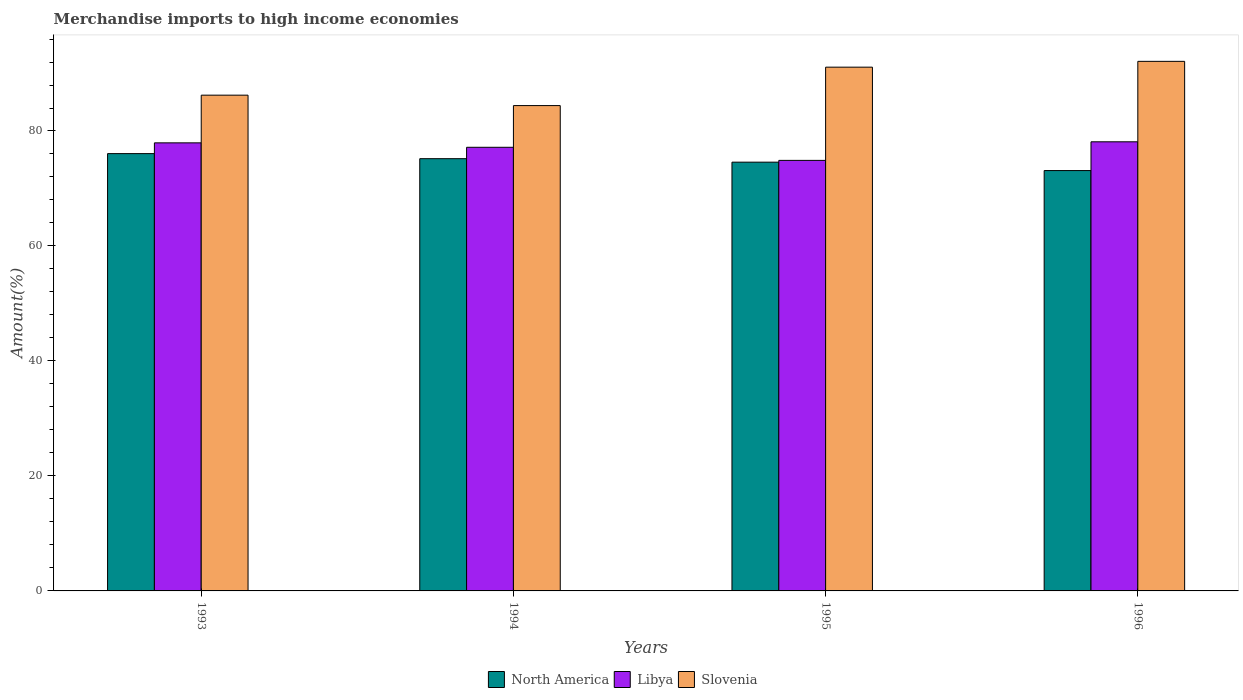Are the number of bars per tick equal to the number of legend labels?
Offer a terse response. Yes. What is the label of the 1st group of bars from the left?
Give a very brief answer. 1993. What is the percentage of amount earned from merchandise imports in North America in 1996?
Provide a short and direct response. 73.12. Across all years, what is the maximum percentage of amount earned from merchandise imports in North America?
Provide a short and direct response. 76.07. Across all years, what is the minimum percentage of amount earned from merchandise imports in Slovenia?
Give a very brief answer. 84.42. In which year was the percentage of amount earned from merchandise imports in Libya maximum?
Provide a short and direct response. 1996. In which year was the percentage of amount earned from merchandise imports in Libya minimum?
Your response must be concise. 1995. What is the total percentage of amount earned from merchandise imports in Slovenia in the graph?
Offer a terse response. 353.87. What is the difference between the percentage of amount earned from merchandise imports in North America in 1993 and that in 1995?
Give a very brief answer. 1.49. What is the difference between the percentage of amount earned from merchandise imports in Slovenia in 1996 and the percentage of amount earned from merchandise imports in Libya in 1995?
Offer a very short reply. 17.23. What is the average percentage of amount earned from merchandise imports in Libya per year?
Offer a terse response. 77.03. In the year 1996, what is the difference between the percentage of amount earned from merchandise imports in Slovenia and percentage of amount earned from merchandise imports in North America?
Your answer should be compact. 19. What is the ratio of the percentage of amount earned from merchandise imports in Slovenia in 1995 to that in 1996?
Keep it short and to the point. 0.99. Is the percentage of amount earned from merchandise imports in Slovenia in 1994 less than that in 1996?
Your answer should be compact. Yes. Is the difference between the percentage of amount earned from merchandise imports in Slovenia in 1995 and 1996 greater than the difference between the percentage of amount earned from merchandise imports in North America in 1995 and 1996?
Provide a succinct answer. No. What is the difference between the highest and the second highest percentage of amount earned from merchandise imports in Libya?
Provide a succinct answer. 0.18. What is the difference between the highest and the lowest percentage of amount earned from merchandise imports in Libya?
Your response must be concise. 3.23. What does the 2nd bar from the left in 1993 represents?
Your answer should be compact. Libya. What does the 2nd bar from the right in 1993 represents?
Give a very brief answer. Libya. Is it the case that in every year, the sum of the percentage of amount earned from merchandise imports in North America and percentage of amount earned from merchandise imports in Slovenia is greater than the percentage of amount earned from merchandise imports in Libya?
Your response must be concise. Yes. What is the difference between two consecutive major ticks on the Y-axis?
Ensure brevity in your answer.  20. Does the graph contain any zero values?
Ensure brevity in your answer.  No. What is the title of the graph?
Provide a short and direct response. Merchandise imports to high income economies. Does "Somalia" appear as one of the legend labels in the graph?
Offer a very short reply. No. What is the label or title of the X-axis?
Keep it short and to the point. Years. What is the label or title of the Y-axis?
Make the answer very short. Amount(%). What is the Amount(%) of North America in 1993?
Your answer should be very brief. 76.07. What is the Amount(%) in Libya in 1993?
Your answer should be very brief. 77.94. What is the Amount(%) of Slovenia in 1993?
Your answer should be very brief. 86.23. What is the Amount(%) of North America in 1994?
Ensure brevity in your answer.  75.18. What is the Amount(%) in Libya in 1994?
Offer a terse response. 77.17. What is the Amount(%) in Slovenia in 1994?
Give a very brief answer. 84.42. What is the Amount(%) in North America in 1995?
Ensure brevity in your answer.  74.58. What is the Amount(%) in Libya in 1995?
Your answer should be compact. 74.89. What is the Amount(%) in Slovenia in 1995?
Ensure brevity in your answer.  91.1. What is the Amount(%) in North America in 1996?
Ensure brevity in your answer.  73.12. What is the Amount(%) of Libya in 1996?
Give a very brief answer. 78.12. What is the Amount(%) in Slovenia in 1996?
Offer a very short reply. 92.11. Across all years, what is the maximum Amount(%) in North America?
Provide a short and direct response. 76.07. Across all years, what is the maximum Amount(%) of Libya?
Make the answer very short. 78.12. Across all years, what is the maximum Amount(%) in Slovenia?
Your answer should be very brief. 92.11. Across all years, what is the minimum Amount(%) of North America?
Offer a terse response. 73.12. Across all years, what is the minimum Amount(%) in Libya?
Your answer should be very brief. 74.89. Across all years, what is the minimum Amount(%) in Slovenia?
Your response must be concise. 84.42. What is the total Amount(%) of North America in the graph?
Provide a succinct answer. 298.94. What is the total Amount(%) in Libya in the graph?
Give a very brief answer. 308.11. What is the total Amount(%) in Slovenia in the graph?
Your answer should be very brief. 353.87. What is the difference between the Amount(%) of North America in 1993 and that in 1994?
Your answer should be compact. 0.88. What is the difference between the Amount(%) of Libya in 1993 and that in 1994?
Provide a short and direct response. 0.77. What is the difference between the Amount(%) of Slovenia in 1993 and that in 1994?
Provide a short and direct response. 1.81. What is the difference between the Amount(%) in North America in 1993 and that in 1995?
Keep it short and to the point. 1.49. What is the difference between the Amount(%) of Libya in 1993 and that in 1995?
Offer a terse response. 3.05. What is the difference between the Amount(%) in Slovenia in 1993 and that in 1995?
Provide a short and direct response. -4.87. What is the difference between the Amount(%) of North America in 1993 and that in 1996?
Your answer should be very brief. 2.95. What is the difference between the Amount(%) of Libya in 1993 and that in 1996?
Keep it short and to the point. -0.18. What is the difference between the Amount(%) of Slovenia in 1993 and that in 1996?
Your response must be concise. -5.88. What is the difference between the Amount(%) in North America in 1994 and that in 1995?
Provide a succinct answer. 0.61. What is the difference between the Amount(%) in Libya in 1994 and that in 1995?
Your answer should be very brief. 2.28. What is the difference between the Amount(%) in Slovenia in 1994 and that in 1995?
Provide a short and direct response. -6.68. What is the difference between the Amount(%) of North America in 1994 and that in 1996?
Ensure brevity in your answer.  2.07. What is the difference between the Amount(%) in Libya in 1994 and that in 1996?
Provide a short and direct response. -0.95. What is the difference between the Amount(%) of Slovenia in 1994 and that in 1996?
Ensure brevity in your answer.  -7.69. What is the difference between the Amount(%) in North America in 1995 and that in 1996?
Your answer should be very brief. 1.46. What is the difference between the Amount(%) of Libya in 1995 and that in 1996?
Keep it short and to the point. -3.23. What is the difference between the Amount(%) in Slovenia in 1995 and that in 1996?
Your answer should be very brief. -1.01. What is the difference between the Amount(%) in North America in 1993 and the Amount(%) in Libya in 1994?
Give a very brief answer. -1.1. What is the difference between the Amount(%) in North America in 1993 and the Amount(%) in Slovenia in 1994?
Your answer should be compact. -8.36. What is the difference between the Amount(%) of Libya in 1993 and the Amount(%) of Slovenia in 1994?
Keep it short and to the point. -6.48. What is the difference between the Amount(%) of North America in 1993 and the Amount(%) of Libya in 1995?
Ensure brevity in your answer.  1.18. What is the difference between the Amount(%) of North America in 1993 and the Amount(%) of Slovenia in 1995?
Your answer should be very brief. -15.04. What is the difference between the Amount(%) in Libya in 1993 and the Amount(%) in Slovenia in 1995?
Make the answer very short. -13.16. What is the difference between the Amount(%) of North America in 1993 and the Amount(%) of Libya in 1996?
Keep it short and to the point. -2.06. What is the difference between the Amount(%) in North America in 1993 and the Amount(%) in Slovenia in 1996?
Give a very brief answer. -16.05. What is the difference between the Amount(%) in Libya in 1993 and the Amount(%) in Slovenia in 1996?
Give a very brief answer. -14.18. What is the difference between the Amount(%) in North America in 1994 and the Amount(%) in Libya in 1995?
Keep it short and to the point. 0.3. What is the difference between the Amount(%) in North America in 1994 and the Amount(%) in Slovenia in 1995?
Keep it short and to the point. -15.92. What is the difference between the Amount(%) in Libya in 1994 and the Amount(%) in Slovenia in 1995?
Offer a very short reply. -13.94. What is the difference between the Amount(%) in North America in 1994 and the Amount(%) in Libya in 1996?
Your answer should be compact. -2.94. What is the difference between the Amount(%) in North America in 1994 and the Amount(%) in Slovenia in 1996?
Provide a succinct answer. -16.93. What is the difference between the Amount(%) of Libya in 1994 and the Amount(%) of Slovenia in 1996?
Provide a succinct answer. -14.95. What is the difference between the Amount(%) of North America in 1995 and the Amount(%) of Libya in 1996?
Provide a succinct answer. -3.54. What is the difference between the Amount(%) of North America in 1995 and the Amount(%) of Slovenia in 1996?
Your answer should be very brief. -17.54. What is the difference between the Amount(%) in Libya in 1995 and the Amount(%) in Slovenia in 1996?
Your response must be concise. -17.23. What is the average Amount(%) in North America per year?
Your response must be concise. 74.74. What is the average Amount(%) in Libya per year?
Offer a very short reply. 77.03. What is the average Amount(%) in Slovenia per year?
Your response must be concise. 88.47. In the year 1993, what is the difference between the Amount(%) in North America and Amount(%) in Libya?
Offer a very short reply. -1.87. In the year 1993, what is the difference between the Amount(%) in North America and Amount(%) in Slovenia?
Keep it short and to the point. -10.17. In the year 1993, what is the difference between the Amount(%) in Libya and Amount(%) in Slovenia?
Ensure brevity in your answer.  -8.3. In the year 1994, what is the difference between the Amount(%) in North America and Amount(%) in Libya?
Keep it short and to the point. -1.98. In the year 1994, what is the difference between the Amount(%) of North America and Amount(%) of Slovenia?
Give a very brief answer. -9.24. In the year 1994, what is the difference between the Amount(%) of Libya and Amount(%) of Slovenia?
Provide a succinct answer. -7.25. In the year 1995, what is the difference between the Amount(%) in North America and Amount(%) in Libya?
Give a very brief answer. -0.31. In the year 1995, what is the difference between the Amount(%) in North America and Amount(%) in Slovenia?
Offer a terse response. -16.52. In the year 1995, what is the difference between the Amount(%) of Libya and Amount(%) of Slovenia?
Offer a terse response. -16.21. In the year 1996, what is the difference between the Amount(%) of North America and Amount(%) of Libya?
Your response must be concise. -5. In the year 1996, what is the difference between the Amount(%) of North America and Amount(%) of Slovenia?
Your answer should be very brief. -19. In the year 1996, what is the difference between the Amount(%) in Libya and Amount(%) in Slovenia?
Ensure brevity in your answer.  -13.99. What is the ratio of the Amount(%) in North America in 1993 to that in 1994?
Your response must be concise. 1.01. What is the ratio of the Amount(%) of Slovenia in 1993 to that in 1994?
Offer a terse response. 1.02. What is the ratio of the Amount(%) in North America in 1993 to that in 1995?
Your answer should be very brief. 1.02. What is the ratio of the Amount(%) in Libya in 1993 to that in 1995?
Make the answer very short. 1.04. What is the ratio of the Amount(%) in Slovenia in 1993 to that in 1995?
Offer a terse response. 0.95. What is the ratio of the Amount(%) in North America in 1993 to that in 1996?
Your response must be concise. 1.04. What is the ratio of the Amount(%) in Libya in 1993 to that in 1996?
Provide a short and direct response. 1. What is the ratio of the Amount(%) in Slovenia in 1993 to that in 1996?
Offer a terse response. 0.94. What is the ratio of the Amount(%) in North America in 1994 to that in 1995?
Provide a succinct answer. 1.01. What is the ratio of the Amount(%) in Libya in 1994 to that in 1995?
Ensure brevity in your answer.  1.03. What is the ratio of the Amount(%) of Slovenia in 1994 to that in 1995?
Offer a terse response. 0.93. What is the ratio of the Amount(%) of North America in 1994 to that in 1996?
Provide a short and direct response. 1.03. What is the ratio of the Amount(%) in Slovenia in 1994 to that in 1996?
Keep it short and to the point. 0.92. What is the ratio of the Amount(%) of North America in 1995 to that in 1996?
Ensure brevity in your answer.  1.02. What is the ratio of the Amount(%) of Libya in 1995 to that in 1996?
Ensure brevity in your answer.  0.96. What is the ratio of the Amount(%) in Slovenia in 1995 to that in 1996?
Offer a very short reply. 0.99. What is the difference between the highest and the second highest Amount(%) of North America?
Keep it short and to the point. 0.88. What is the difference between the highest and the second highest Amount(%) in Libya?
Offer a terse response. 0.18. What is the difference between the highest and the second highest Amount(%) in Slovenia?
Make the answer very short. 1.01. What is the difference between the highest and the lowest Amount(%) of North America?
Your answer should be compact. 2.95. What is the difference between the highest and the lowest Amount(%) of Libya?
Ensure brevity in your answer.  3.23. What is the difference between the highest and the lowest Amount(%) of Slovenia?
Give a very brief answer. 7.69. 